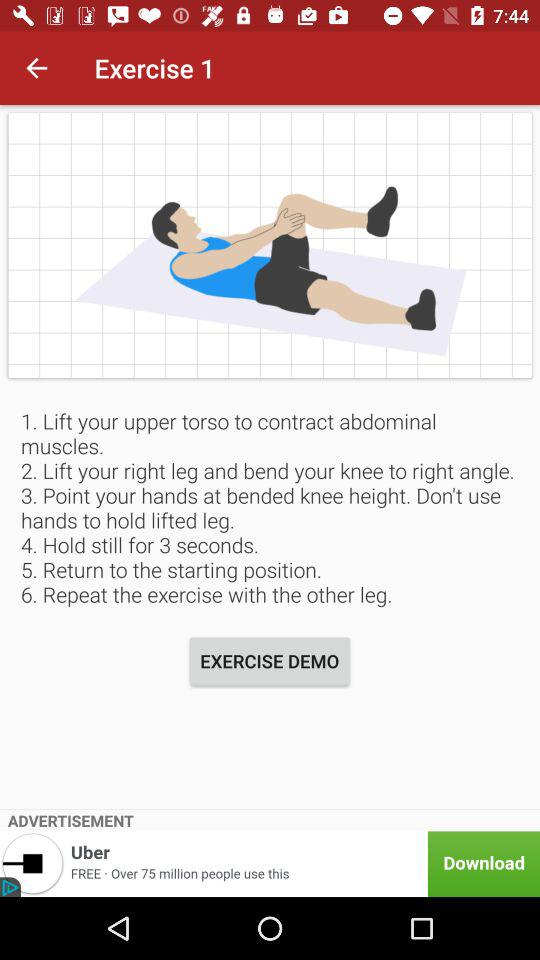How many people have downloaded the app?
Answer the question using a single word or phrase. 75 million 